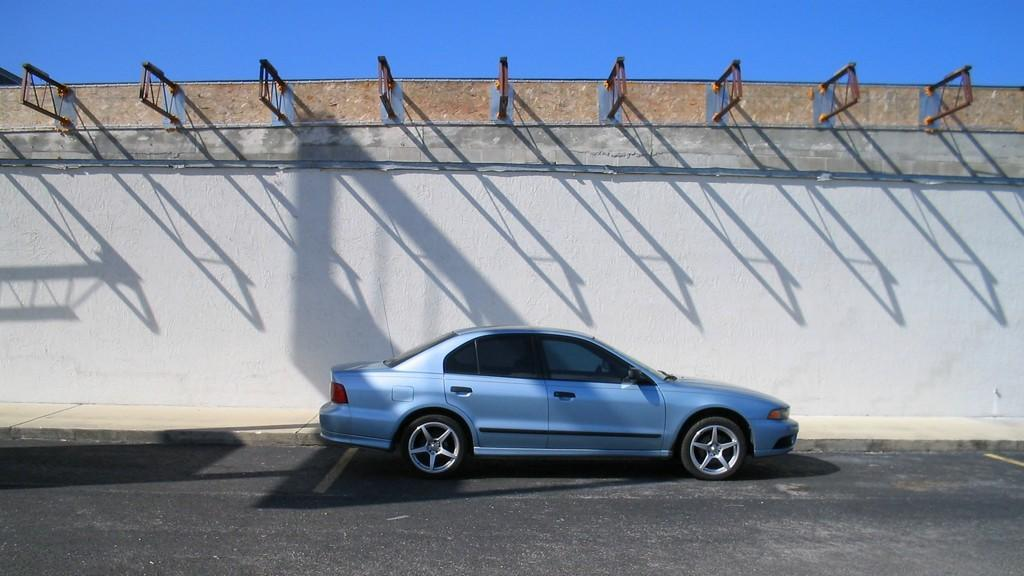What is the main subject of the image? There is a car in the image. What is the car doing in the image? The car is moving in the image. Where is the car located in relation to other objects? The car is beside a wall in the image. What color is the car? The car is blue in color. What type of watch is the car wearing in the image? There is no watch present in the image, as cars do not wear watches. 